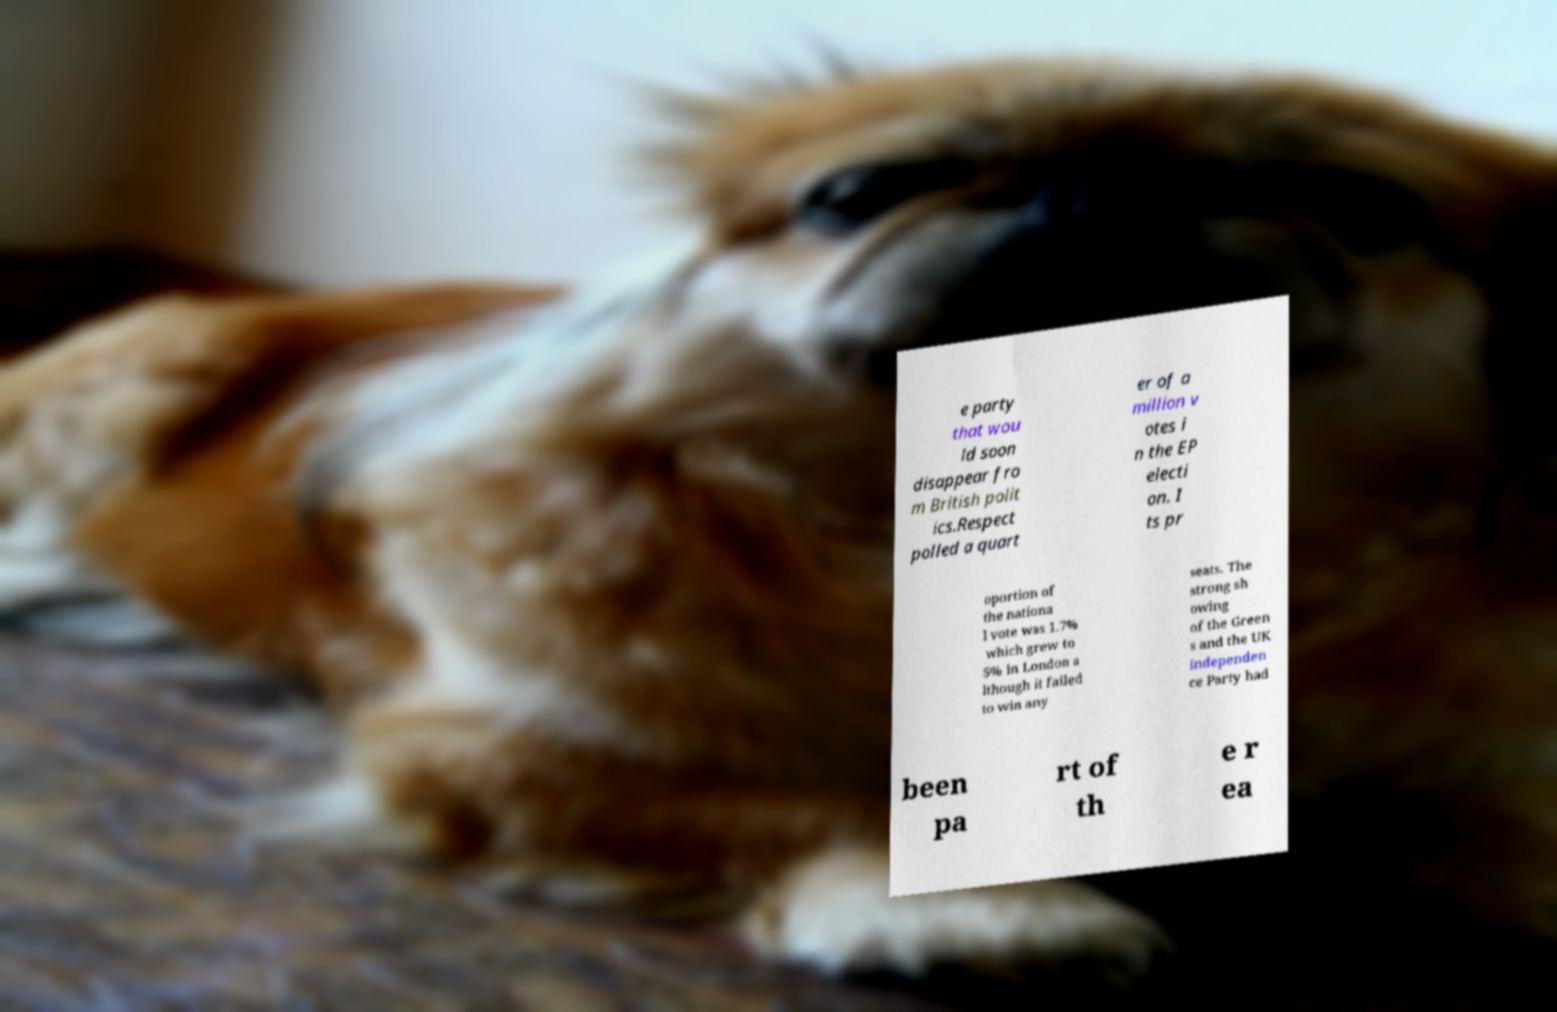There's text embedded in this image that I need extracted. Can you transcribe it verbatim? e party that wou ld soon disappear fro m British polit ics.Respect polled a quart er of a million v otes i n the EP electi on. I ts pr oportion of the nationa l vote was 1.7% which grew to 5% in London a lthough it failed to win any seats. The strong sh owing of the Green s and the UK Independen ce Party had been pa rt of th e r ea 